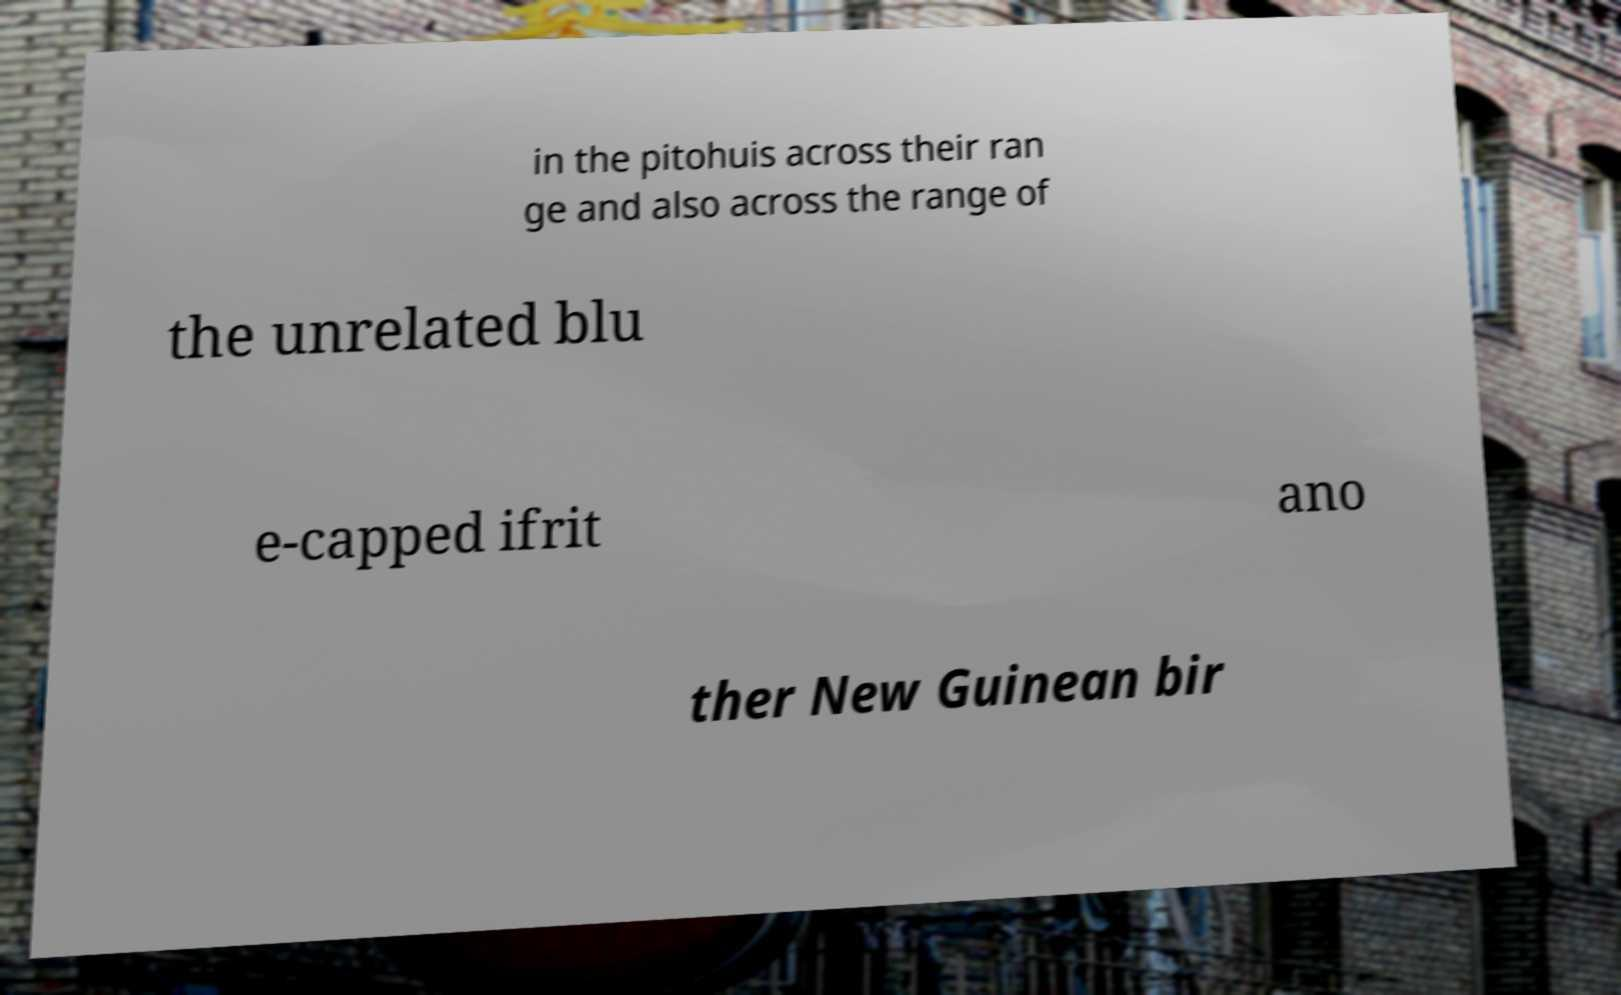What messages or text are displayed in this image? I need them in a readable, typed format. in the pitohuis across their ran ge and also across the range of the unrelated blu e-capped ifrit ano ther New Guinean bir 